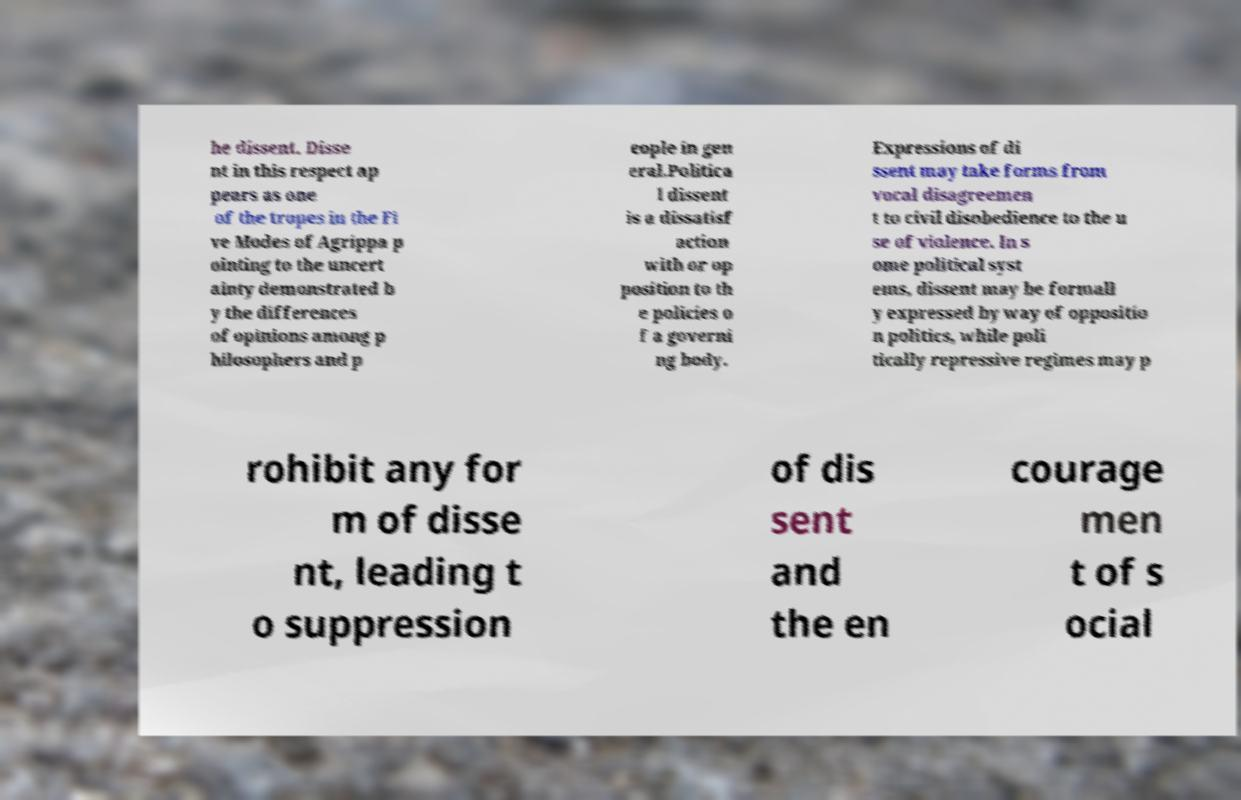Please read and relay the text visible in this image. What does it say? he dissent. Disse nt in this respect ap pears as one of the tropes in the Fi ve Modes of Agrippa p ointing to the uncert ainty demonstrated b y the differences of opinions among p hilosophers and p eople in gen eral.Politica l dissent is a dissatisf action with or op position to th e policies o f a governi ng body. Expressions of di ssent may take forms from vocal disagreemen t to civil disobedience to the u se of violence. In s ome political syst ems, dissent may be formall y expressed by way of oppositio n politics, while poli tically repressive regimes may p rohibit any for m of disse nt, leading t o suppression of dis sent and the en courage men t of s ocial 